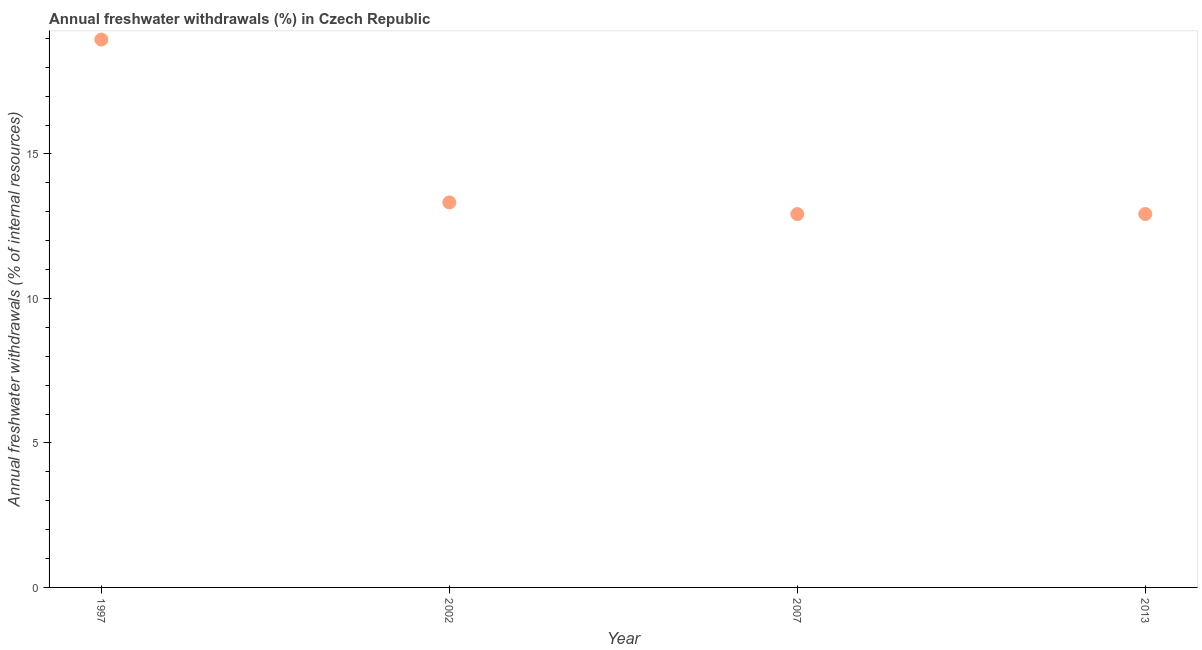What is the annual freshwater withdrawals in 2002?
Your answer should be very brief. 13.32. Across all years, what is the maximum annual freshwater withdrawals?
Your answer should be very brief. 18.96. Across all years, what is the minimum annual freshwater withdrawals?
Offer a very short reply. 12.92. In which year was the annual freshwater withdrawals maximum?
Provide a succinct answer. 1997. What is the sum of the annual freshwater withdrawals?
Keep it short and to the point. 58.12. What is the difference between the annual freshwater withdrawals in 1997 and 2002?
Keep it short and to the point. 5.63. What is the average annual freshwater withdrawals per year?
Offer a very short reply. 14.53. What is the median annual freshwater withdrawals?
Offer a very short reply. 13.12. Do a majority of the years between 1997 and 2013 (inclusive) have annual freshwater withdrawals greater than 3 %?
Keep it short and to the point. Yes. What is the ratio of the annual freshwater withdrawals in 1997 to that in 2007?
Provide a short and direct response. 1.47. Is the annual freshwater withdrawals in 1997 less than that in 2007?
Provide a short and direct response. No. Is the difference between the annual freshwater withdrawals in 1997 and 2013 greater than the difference between any two years?
Your answer should be compact. Yes. What is the difference between the highest and the second highest annual freshwater withdrawals?
Make the answer very short. 5.63. What is the difference between the highest and the lowest annual freshwater withdrawals?
Ensure brevity in your answer.  6.04. Does the annual freshwater withdrawals monotonically increase over the years?
Ensure brevity in your answer.  No. How many years are there in the graph?
Keep it short and to the point. 4. What is the difference between two consecutive major ticks on the Y-axis?
Provide a succinct answer. 5. Are the values on the major ticks of Y-axis written in scientific E-notation?
Offer a very short reply. No. Does the graph contain grids?
Provide a short and direct response. No. What is the title of the graph?
Offer a very short reply. Annual freshwater withdrawals (%) in Czech Republic. What is the label or title of the Y-axis?
Provide a succinct answer. Annual freshwater withdrawals (% of internal resources). What is the Annual freshwater withdrawals (% of internal resources) in 1997?
Make the answer very short. 18.96. What is the Annual freshwater withdrawals (% of internal resources) in 2002?
Ensure brevity in your answer.  13.32. What is the Annual freshwater withdrawals (% of internal resources) in 2007?
Your answer should be compact. 12.92. What is the Annual freshwater withdrawals (% of internal resources) in 2013?
Offer a terse response. 12.92. What is the difference between the Annual freshwater withdrawals (% of internal resources) in 1997 and 2002?
Your answer should be very brief. 5.63. What is the difference between the Annual freshwater withdrawals (% of internal resources) in 1997 and 2007?
Offer a terse response. 6.04. What is the difference between the Annual freshwater withdrawals (% of internal resources) in 1997 and 2013?
Ensure brevity in your answer.  6.04. What is the difference between the Annual freshwater withdrawals (% of internal resources) in 2002 and 2007?
Keep it short and to the point. 0.4. What is the difference between the Annual freshwater withdrawals (% of internal resources) in 2002 and 2013?
Keep it short and to the point. 0.4. What is the ratio of the Annual freshwater withdrawals (% of internal resources) in 1997 to that in 2002?
Your answer should be very brief. 1.42. What is the ratio of the Annual freshwater withdrawals (% of internal resources) in 1997 to that in 2007?
Provide a succinct answer. 1.47. What is the ratio of the Annual freshwater withdrawals (% of internal resources) in 1997 to that in 2013?
Offer a terse response. 1.47. What is the ratio of the Annual freshwater withdrawals (% of internal resources) in 2002 to that in 2007?
Ensure brevity in your answer.  1.03. What is the ratio of the Annual freshwater withdrawals (% of internal resources) in 2002 to that in 2013?
Offer a very short reply. 1.03. 